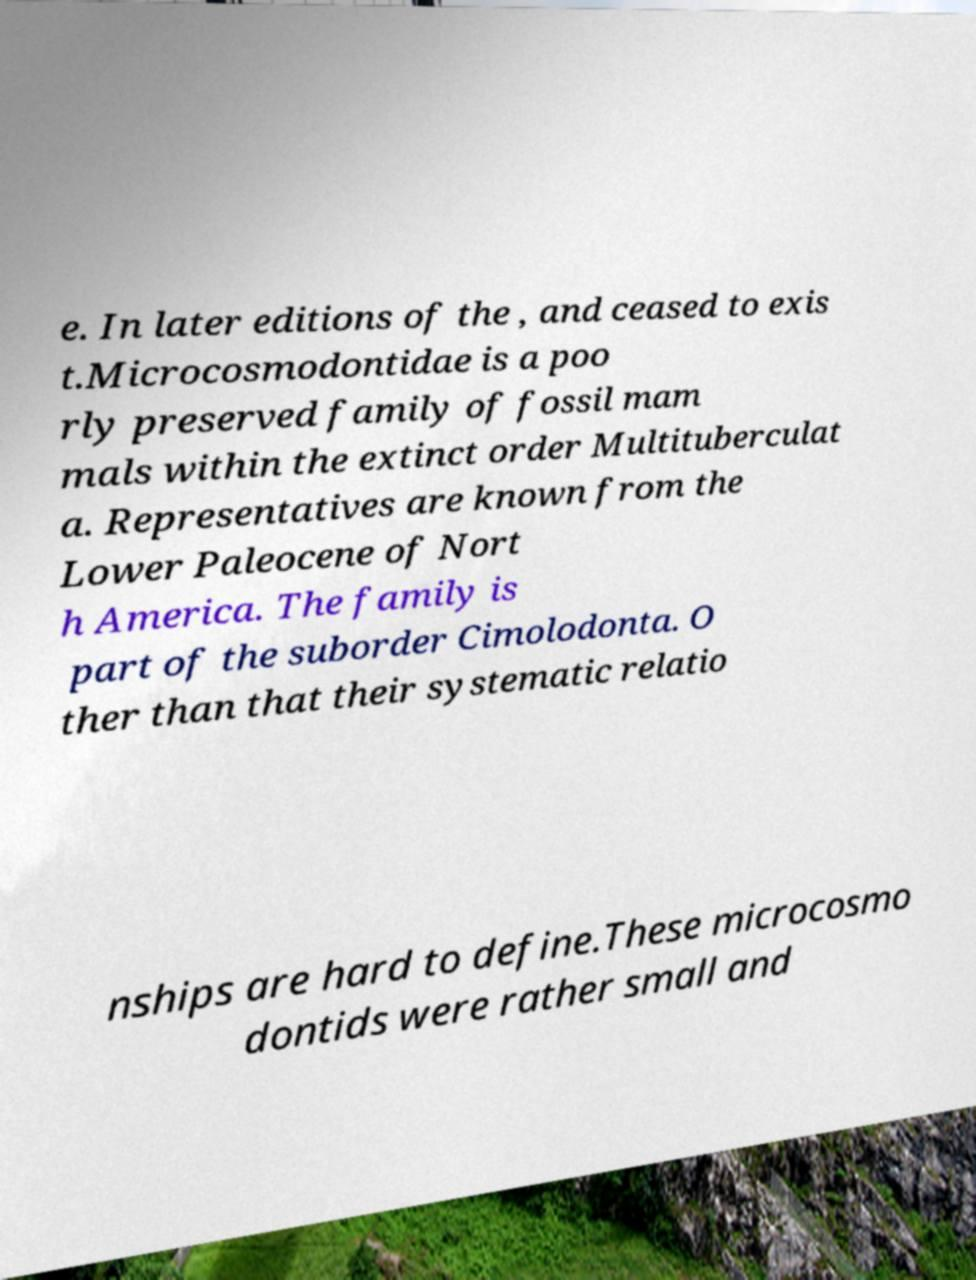Please identify and transcribe the text found in this image. e. In later editions of the , and ceased to exis t.Microcosmodontidae is a poo rly preserved family of fossil mam mals within the extinct order Multituberculat a. Representatives are known from the Lower Paleocene of Nort h America. The family is part of the suborder Cimolodonta. O ther than that their systematic relatio nships are hard to define.These microcosmo dontids were rather small and 